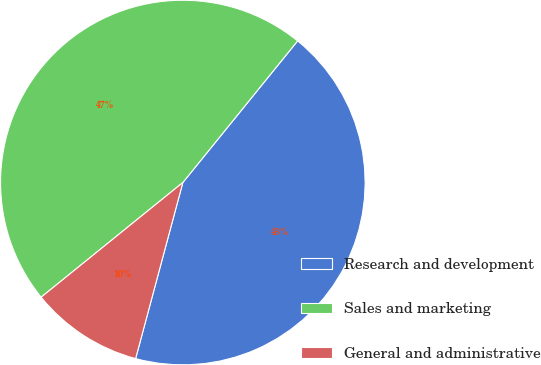Convert chart. <chart><loc_0><loc_0><loc_500><loc_500><pie_chart><fcel>Research and development<fcel>Sales and marketing<fcel>General and administrative<nl><fcel>43.33%<fcel>46.67%<fcel>10.0%<nl></chart> 